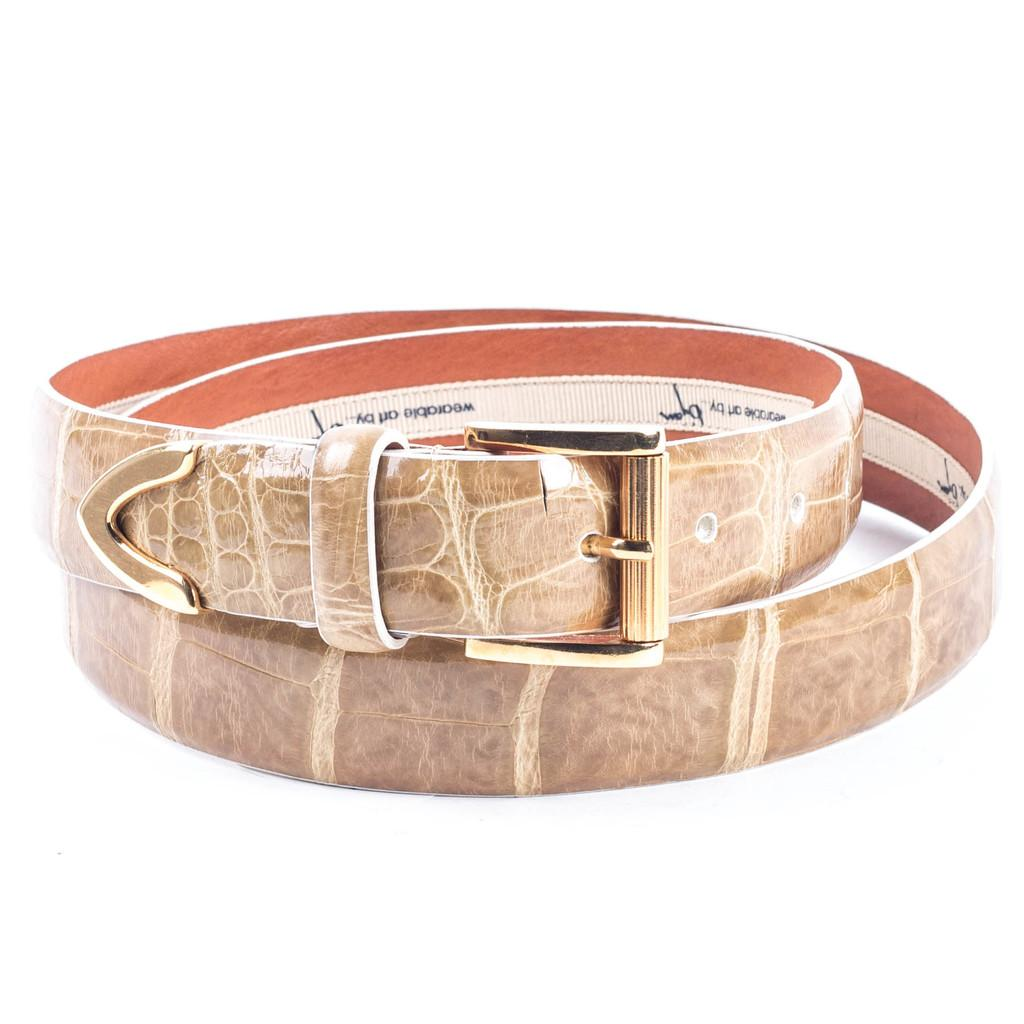What is the main subject of the image? The main subject of the image is a belt. Can you describe the location of the belt in the image? The belt is in the center of the image. What type of ink is being used to color the rabbit in the image? There is no rabbit present in the image, and therefore no ink is being used to color it. 